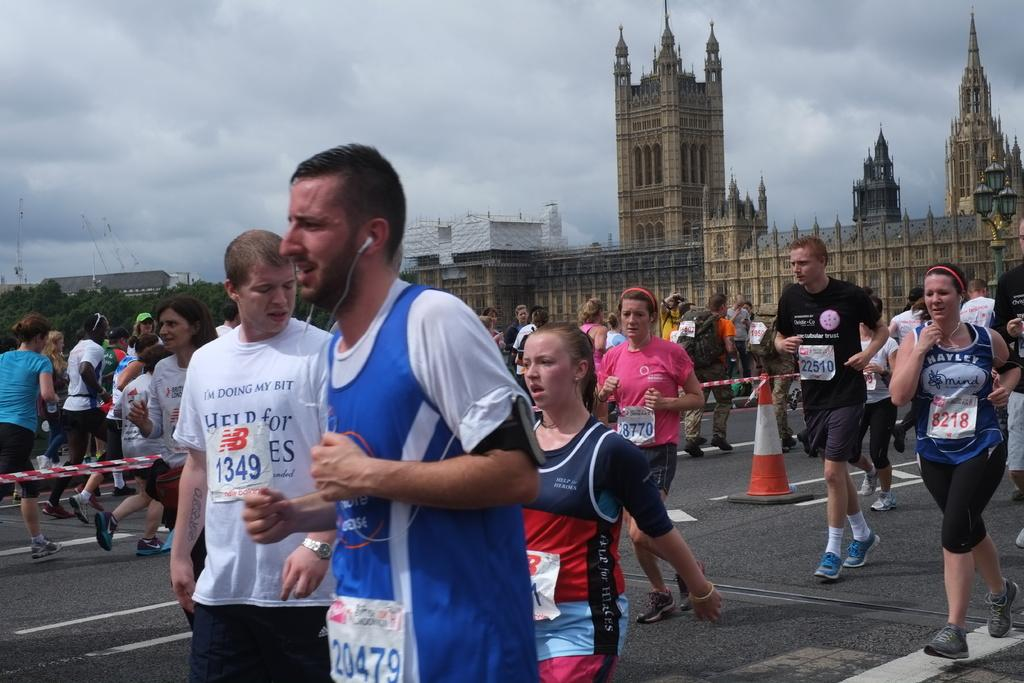What are the people in the image doing? The people in the image are running. What can be seen in the background of the image? There are buildings, trees, and the sky visible in the background of the image. What object can be seen in the image that is typically used for traffic control? There is a traffic cone in the image. How many spiders are crawling on the traffic cone in the image? There are no spiders visible on the traffic cone in the image. What type of sail can be seen in the image? There is no sail present in the image. 